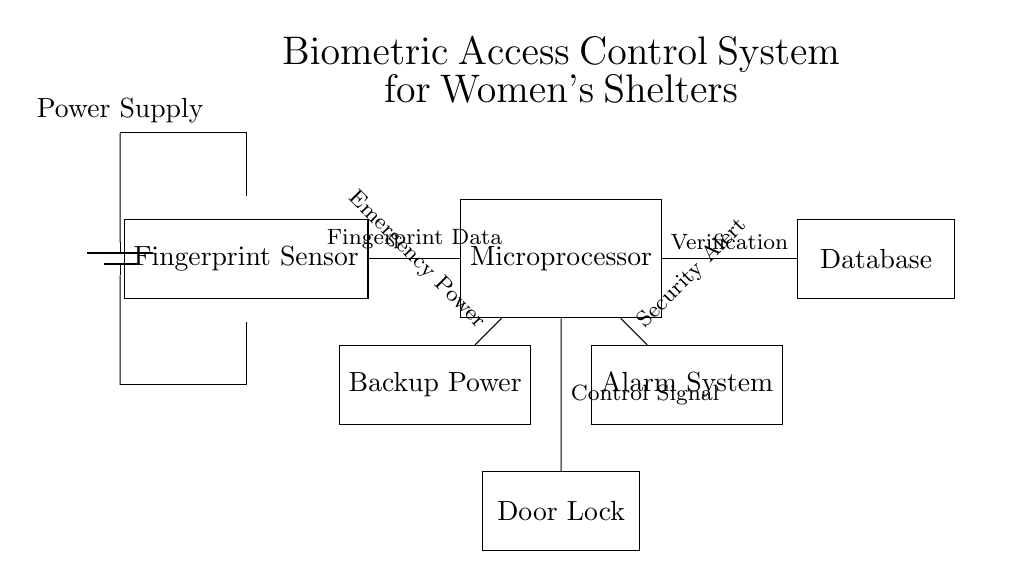What is the main function of the fingerprint sensor? The fingerprint sensor is responsible for capturing the biometric data of users, specifically their fingerprints, which is the first step in user authentication in the system.
Answer: Capturing fingerprints What component generates control signals for the door lock? The microprocessor receives the fingerprint data, processes it, and generates the control signals that unlock or lock the door, ensuring only authorized users can enter.
Answer: Microprocessor Which device stores the verified fingerprint data? The database is the component designated to store the verified fingerprint data, enabling the microprocessor to reference it when authenticating users.
Answer: Database How many total components are in the circuit diagram? By counting the components shown, there are six main components in the circuit: the fingerprint sensor, microprocessor, database, door lock, alarm system, and backup power unit.
Answer: Six What type of system is represented in the diagram? The circuit diagram illustrates a biometric access control system, specifically designed to enhance security within women's shelters by using fingerprint recognition technology.
Answer: Biometric access control What is the purpose of the alarm system in this circuit? The alarm system's purpose is to provide a security alert in case of unauthorized access attempts, supplemented by the control signals from the microprocessor for real-time monitoring.
Answer: Security alert What additional feature does the backup power provide? The backup power ensures that the microprocessor remains operational during a power outage, allowing the system to maintain functionality and security regardless of external power conditions.
Answer: Emergency power 